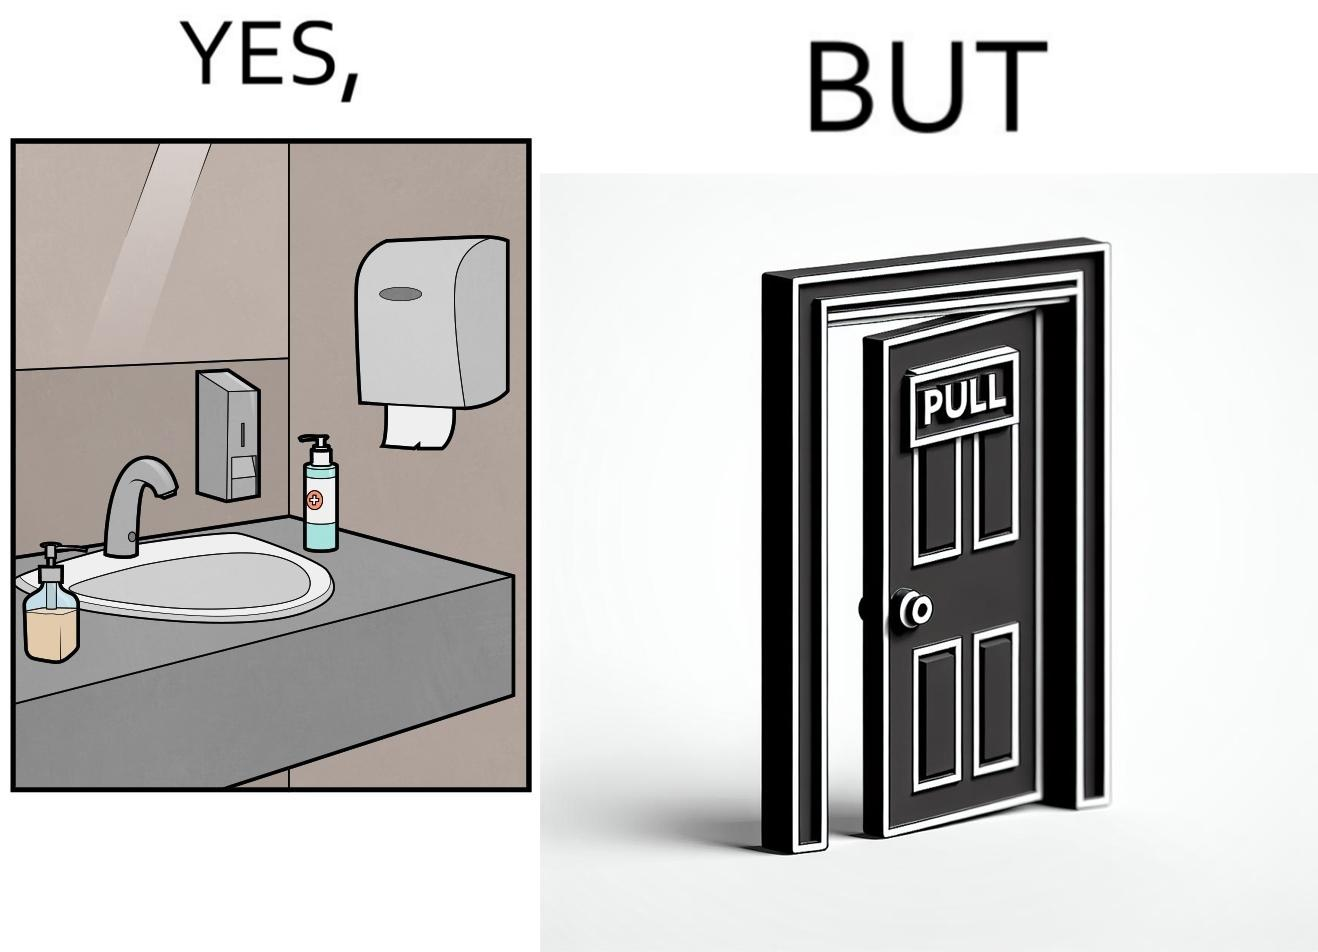What is shown in this image? The image is ironic, because in the first image in the bathroom there are so many things to clean hands around the basin but in the same bathroom people have to open the doors by hand which can easily spread the germs or bacteria even after times of hand cleaning as there is no way to open it without hands 